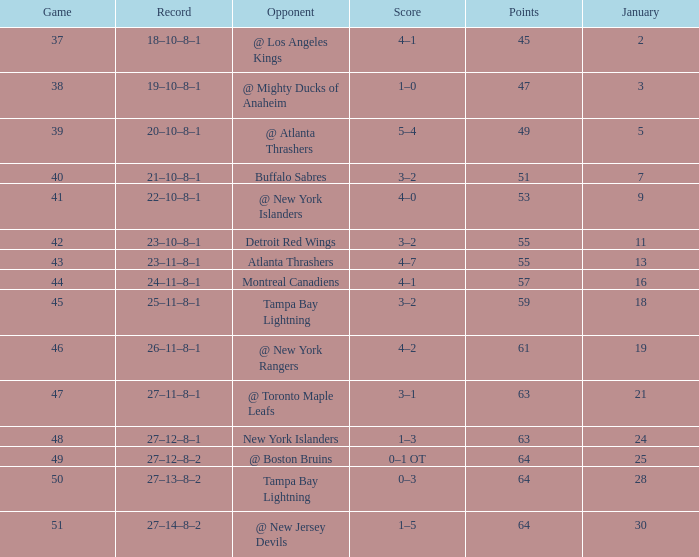Which Score has Points of 64, and a Game of 49? 0–1 OT. 